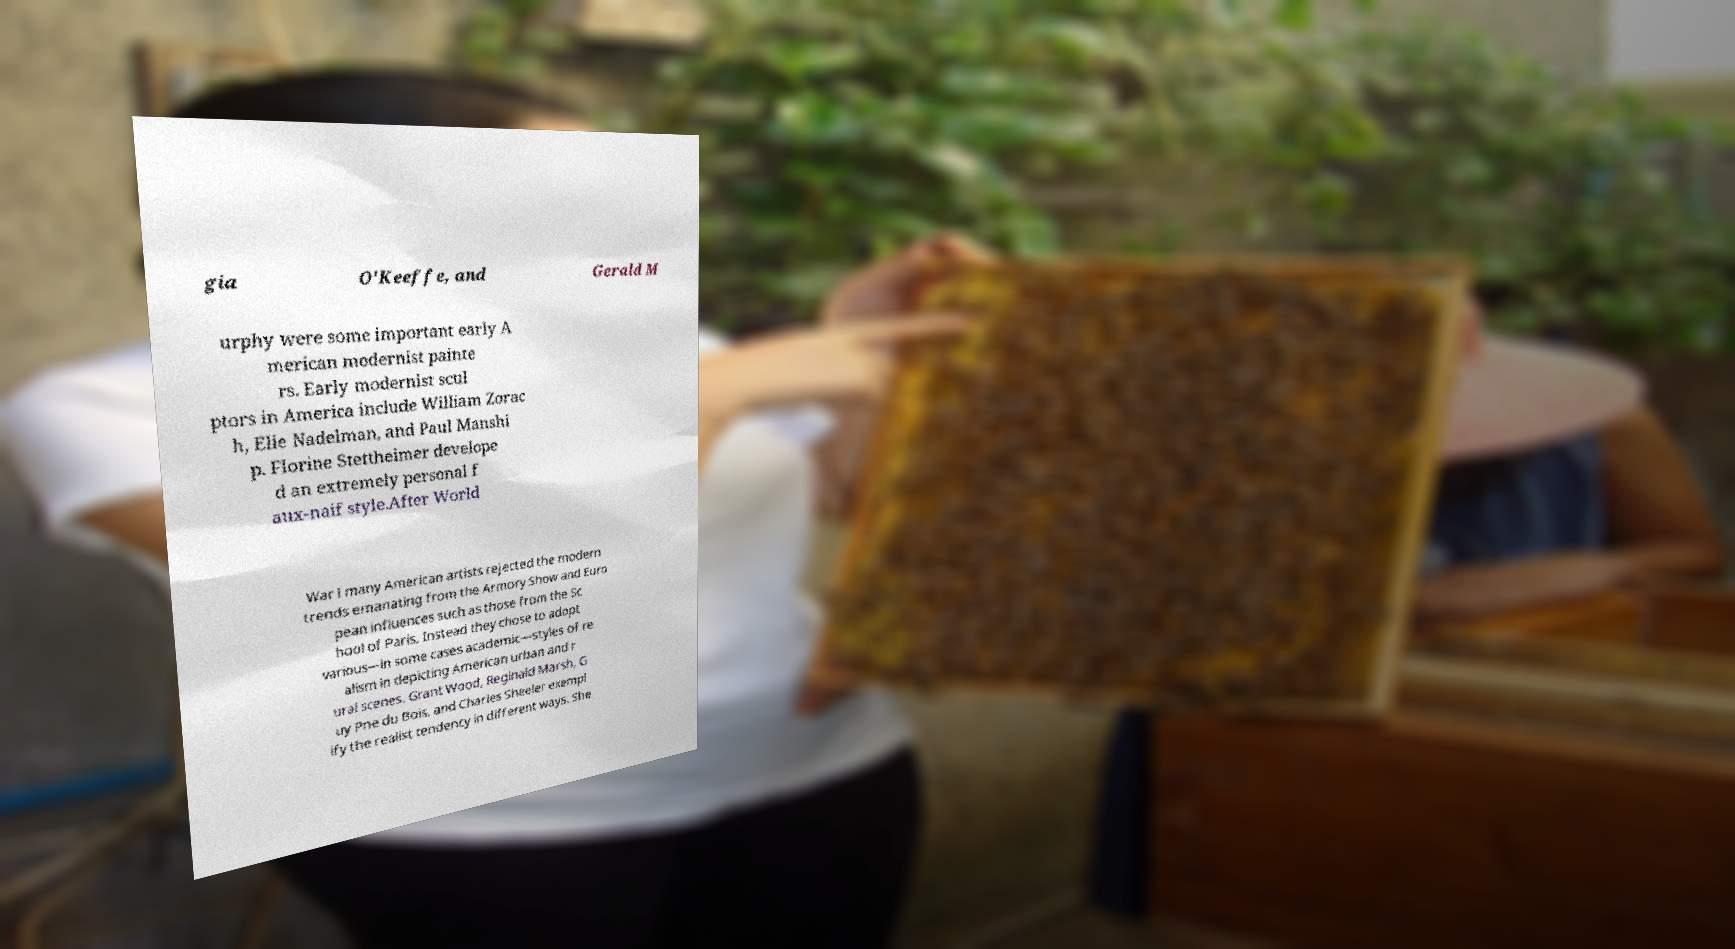Can you accurately transcribe the text from the provided image for me? gia O'Keeffe, and Gerald M urphy were some important early A merican modernist painte rs. Early modernist scul ptors in America include William Zorac h, Elie Nadelman, and Paul Manshi p. Florine Stettheimer develope d an extremely personal f aux-naif style.After World War I many American artists rejected the modern trends emanating from the Armory Show and Euro pean influences such as those from the Sc hool of Paris. Instead they chose to adopt various—in some cases academic—styles of re alism in depicting American urban and r ural scenes. Grant Wood, Reginald Marsh, G uy Pne du Bois, and Charles Sheeler exempl ify the realist tendency in different ways. She 